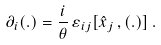<formula> <loc_0><loc_0><loc_500><loc_500>\partial _ { i } ( . ) = \frac { i } { \theta } \, \varepsilon _ { i j } [ { \hat { x } } _ { j } \, , ( . ) ] \, .</formula> 